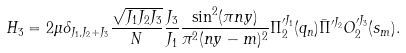Convert formula to latex. <formula><loc_0><loc_0><loc_500><loc_500>H _ { 3 } = 2 \mu \delta _ { J _ { 1 } , J _ { 2 } + J _ { 3 } } { \frac { \sqrt { J _ { 1 } J _ { 2 } J _ { 3 } } } { N } } { \frac { J _ { 3 } } { J _ { 1 } } } { \frac { \sin ^ { 2 } ( \pi n y ) } { \pi ^ { 2 } ( n y - m ) ^ { 2 } } } \Pi _ { 2 } ^ { \prime J _ { 1 } } ( q _ { n } ) \bar { \Pi } ^ { \prime J _ { 2 } } O _ { 2 } ^ { \prime J _ { 3 } } ( s _ { m } ) .</formula> 